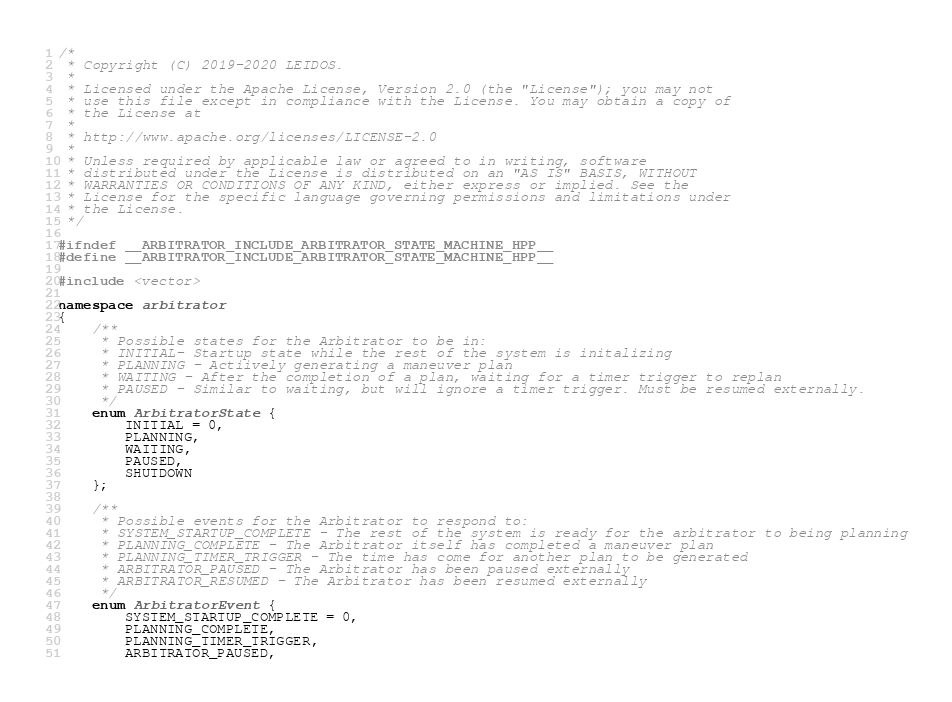<code> <loc_0><loc_0><loc_500><loc_500><_C++_>/*
 * Copyright (C) 2019-2020 LEIDOS.
 *
 * Licensed under the Apache License, Version 2.0 (the "License"); you may not
 * use this file except in compliance with the License. You may obtain a copy of
 * the License at
 *
 * http://www.apache.org/licenses/LICENSE-2.0
 *
 * Unless required by applicable law or agreed to in writing, software
 * distributed under the License is distributed on an "AS IS" BASIS, WITHOUT
 * WARRANTIES OR CONDITIONS OF ANY KIND, either express or implied. See the
 * License for the specific language governing permissions and limitations under
 * the License.
 */

#ifndef __ARBITRATOR_INCLUDE_ARBITRATOR_STATE_MACHINE_HPP__
#define __ARBITRATOR_INCLUDE_ARBITRATOR_STATE_MACHINE_HPP__

#include <vector>

namespace arbitrator
{
    /**
     * Possible states for the Arbitrator to be in:
     * INITIAL- Startup state while the rest of the system is initalizing
     * PLANNING - Actiively generating a maneuver plan
     * WAITING - After the completion of a plan, waiting for a timer trigger to replan
     * PAUSED - Similar to waiting, but will ignore a timer trigger. Must be resumed externally.
     */
    enum ArbitratorState {
        INITIAL = 0,
        PLANNING,
        WAITING,
        PAUSED,
        SHUTDOWN
    };

    /**
     * Possible events for the Arbitrator to respond to:
     * SYSTEM_STARTUP_COMPLETE - The rest of the system is ready for the arbitrator to being planning
     * PLANNING_COMPLETE - The Arbitrator itself has completed a maneuver plan
     * PLANNING_TIMER_TRIGGER - The time has come for another plan to be generated
     * ARBITRATOR_PAUSED - The Arbitrator has been paused externally
     * ARBITRATOR_RESUMED - The Arbitrator has been resumed externally
     */
    enum ArbitratorEvent {
        SYSTEM_STARTUP_COMPLETE = 0,
        PLANNING_COMPLETE,
        PLANNING_TIMER_TRIGGER,
        ARBITRATOR_PAUSED,</code> 